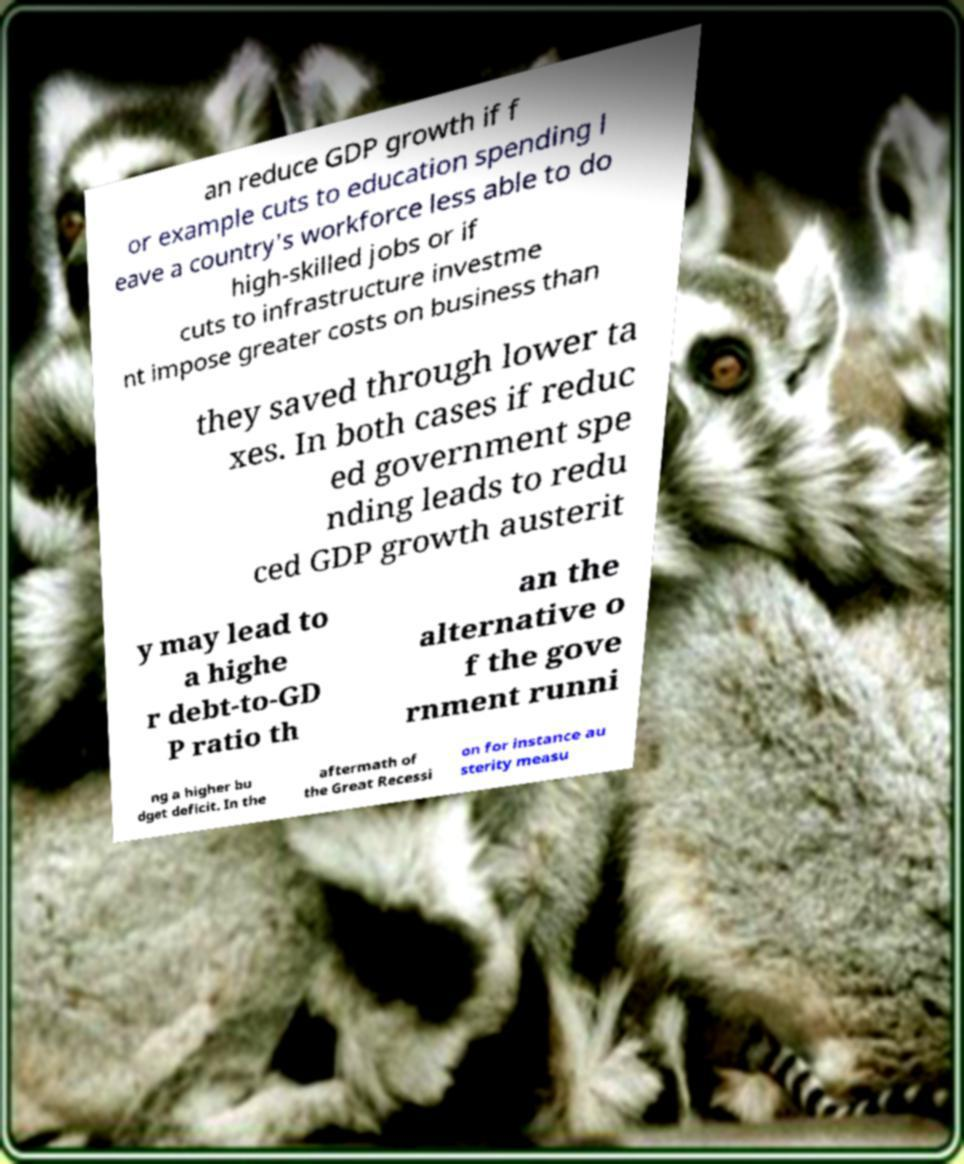Can you accurately transcribe the text from the provided image for me? an reduce GDP growth if f or example cuts to education spending l eave a country's workforce less able to do high-skilled jobs or if cuts to infrastructure investme nt impose greater costs on business than they saved through lower ta xes. In both cases if reduc ed government spe nding leads to redu ced GDP growth austerit y may lead to a highe r debt-to-GD P ratio th an the alternative o f the gove rnment runni ng a higher bu dget deficit. In the aftermath of the Great Recessi on for instance au sterity measu 